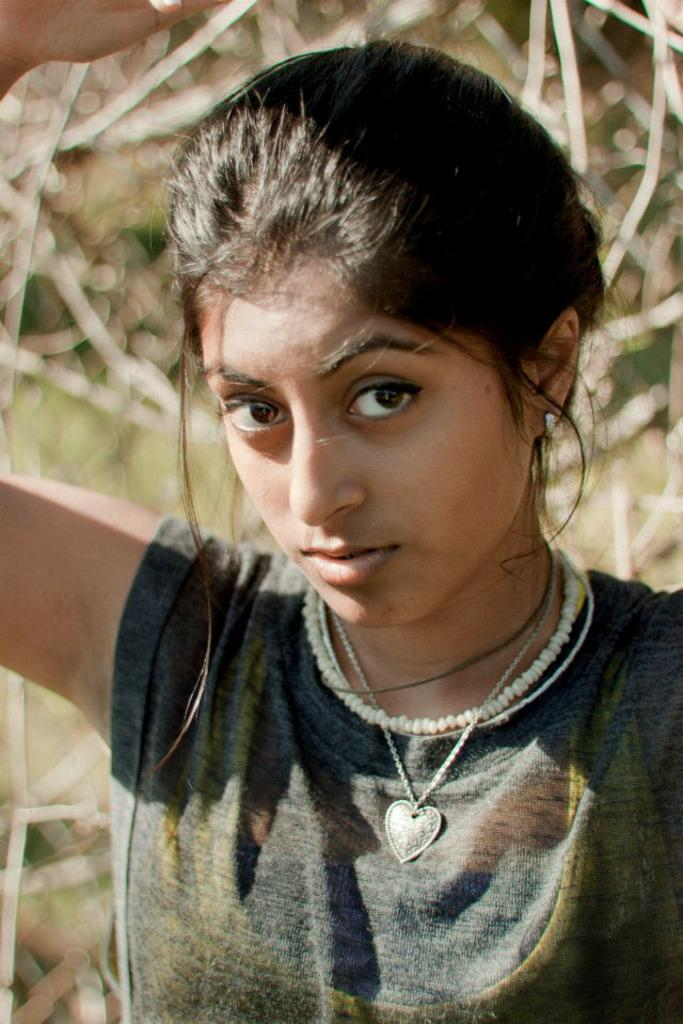Who is the main subject in the image? There is a woman in the image. What is the woman doing in the image? The woman is present over a place, which suggests she might be standing or hovering over it. What can be seen in the background of the image? There are plants visible in the background of the image, but they appear blurry. What type of health advice is the woman giving in the image? There is no indication in the image that the woman is giving any health advice, as the image does not show any specific context or interaction. 